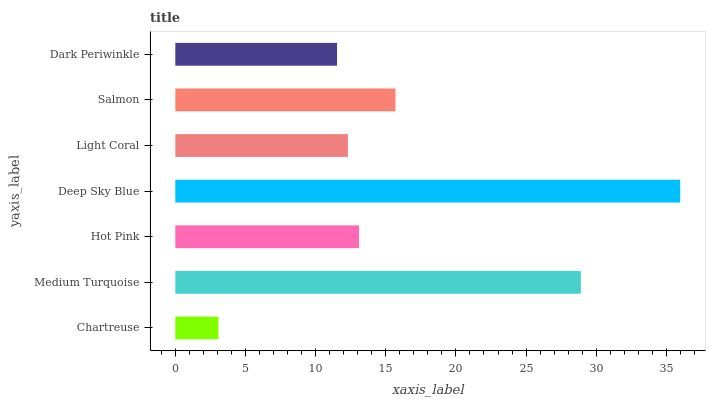Is Chartreuse the minimum?
Answer yes or no. Yes. Is Deep Sky Blue the maximum?
Answer yes or no. Yes. Is Medium Turquoise the minimum?
Answer yes or no. No. Is Medium Turquoise the maximum?
Answer yes or no. No. Is Medium Turquoise greater than Chartreuse?
Answer yes or no. Yes. Is Chartreuse less than Medium Turquoise?
Answer yes or no. Yes. Is Chartreuse greater than Medium Turquoise?
Answer yes or no. No. Is Medium Turquoise less than Chartreuse?
Answer yes or no. No. Is Hot Pink the high median?
Answer yes or no. Yes. Is Hot Pink the low median?
Answer yes or no. Yes. Is Light Coral the high median?
Answer yes or no. No. Is Salmon the low median?
Answer yes or no. No. 